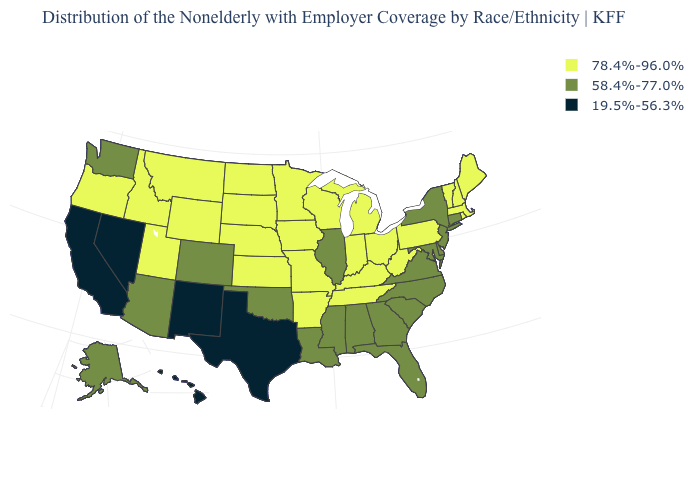Name the states that have a value in the range 78.4%-96.0%?
Concise answer only. Arkansas, Idaho, Indiana, Iowa, Kansas, Kentucky, Maine, Massachusetts, Michigan, Minnesota, Missouri, Montana, Nebraska, New Hampshire, North Dakota, Ohio, Oregon, Pennsylvania, Rhode Island, South Dakota, Tennessee, Utah, Vermont, West Virginia, Wisconsin, Wyoming. What is the value of Nebraska?
Give a very brief answer. 78.4%-96.0%. Name the states that have a value in the range 78.4%-96.0%?
Keep it brief. Arkansas, Idaho, Indiana, Iowa, Kansas, Kentucky, Maine, Massachusetts, Michigan, Minnesota, Missouri, Montana, Nebraska, New Hampshire, North Dakota, Ohio, Oregon, Pennsylvania, Rhode Island, South Dakota, Tennessee, Utah, Vermont, West Virginia, Wisconsin, Wyoming. Does the map have missing data?
Be succinct. No. Name the states that have a value in the range 19.5%-56.3%?
Give a very brief answer. California, Hawaii, Nevada, New Mexico, Texas. Does Alaska have the highest value in the USA?
Keep it brief. No. How many symbols are there in the legend?
Write a very short answer. 3. Which states hav the highest value in the South?
Be succinct. Arkansas, Kentucky, Tennessee, West Virginia. Among the states that border Washington , which have the highest value?
Write a very short answer. Idaho, Oregon. Does California have the lowest value in the USA?
Be succinct. Yes. Does Kentucky have a higher value than Illinois?
Quick response, please. Yes. Does Massachusetts have the highest value in the USA?
Concise answer only. Yes. What is the value of Wyoming?
Answer briefly. 78.4%-96.0%. Which states have the lowest value in the USA?
Write a very short answer. California, Hawaii, Nevada, New Mexico, Texas. 